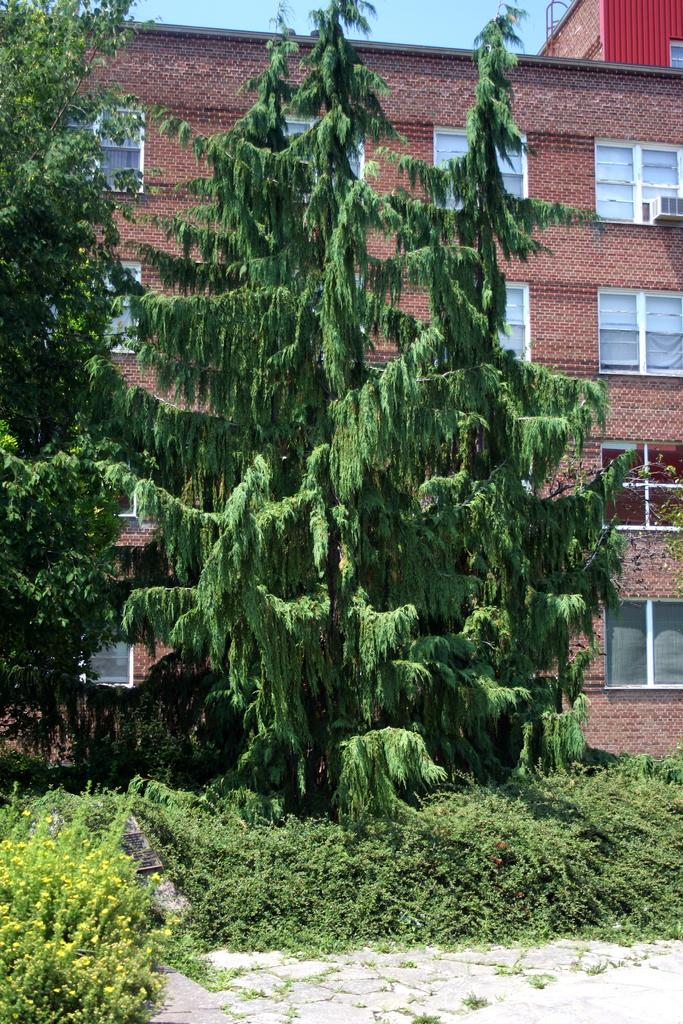What type of vegetation is present in the image? There are plants and trees in the image. What can be seen in the background of the image? There is a building, windows, and the sky visible in the background of the image. How many bushes are present in the image? There is no specific mention of bushes in the image; it only mentions plants and trees. Can you tell me how many servants are visible in the image? There is no mention of any servants in the image. What type of substance is being used by the plants in the image? There is no information about any substances being used by the plants in the image. 